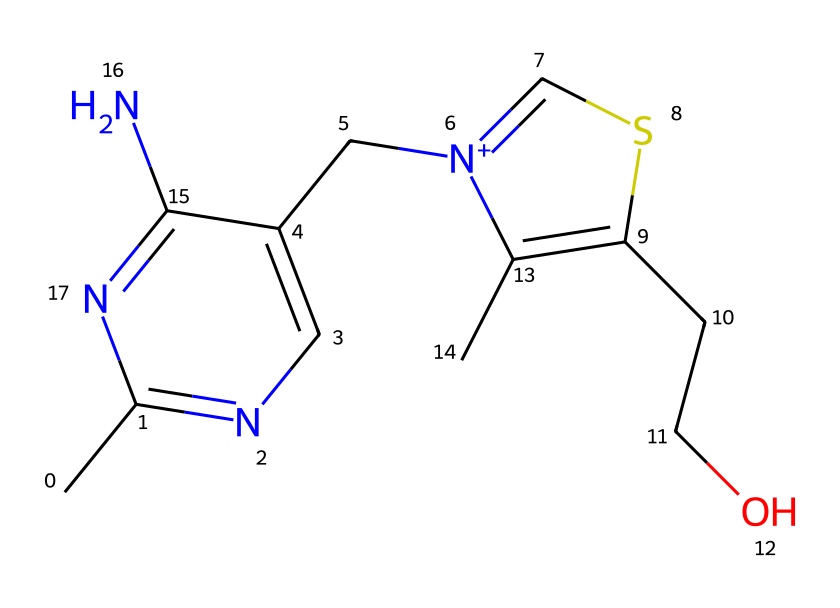What is the total number of nitrogen atoms in the structure? The SMILES representation of thiamine contains two 'n' characters, indicating the presence of two nitrogen atoms. Thus, by counting the occurrences of 'n', we determine the total number of nitrogen atoms.
Answer: two How many carbon atoms are present in thiamine? To count the carbon atoms in the provided SMILES, we can identify the 'C' characters. The structure includes six 'C' characters which represent six carbon atoms.
Answer: six What functional group is primarily responsible for thiamine's role as a vitamin? Thiamine features a thiazole ring which contains sulfur and nitrogen, contributing to its essential role in energy metabolism as a vitamin.
Answer: thiazole Which atom in thiamine distinguishes it from other B vitamins? The presence of a sulfur atom in the thiazole ring distinguishes thiamine from other B vitamins, which do not contain sulfur.
Answer: sulfur Is thiamine a polar or nonpolar molecule? The presence of multiple functional groups, including amine and hydroxyl, suggests that thiamine is polar due to its ability to form hydrogen bonds.
Answer: polar How does the presence of the sulfur atom influence thiamine's solubility? The sulfur atom contributes to thiamine's solubility in water as it can participate in hydrogen bonding and other interactions, enhancing its overall solubility in polar solvents.
Answer: enhances 